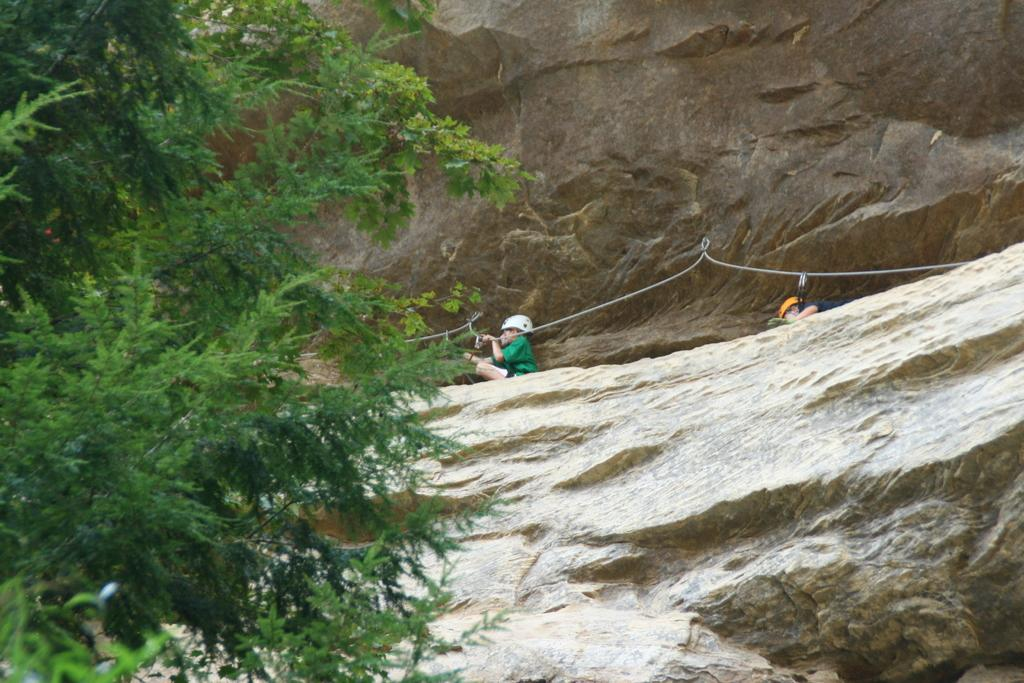Who is present in the image? There are kids in the image. What are the kids sitting on? The kids are sitting on a rock. What are the kids holding in their hands? The kids are holding ropes. What protective gear are the kids wearing? The kids are wearing helmets. What type of natural environment can be seen in the image? There are trees in the image. What type of key is hanging from the tree in the image? There is no key present in the image; it only features kids sitting on a rock, holding ropes, and wearing helmets, along with trees in the background. 